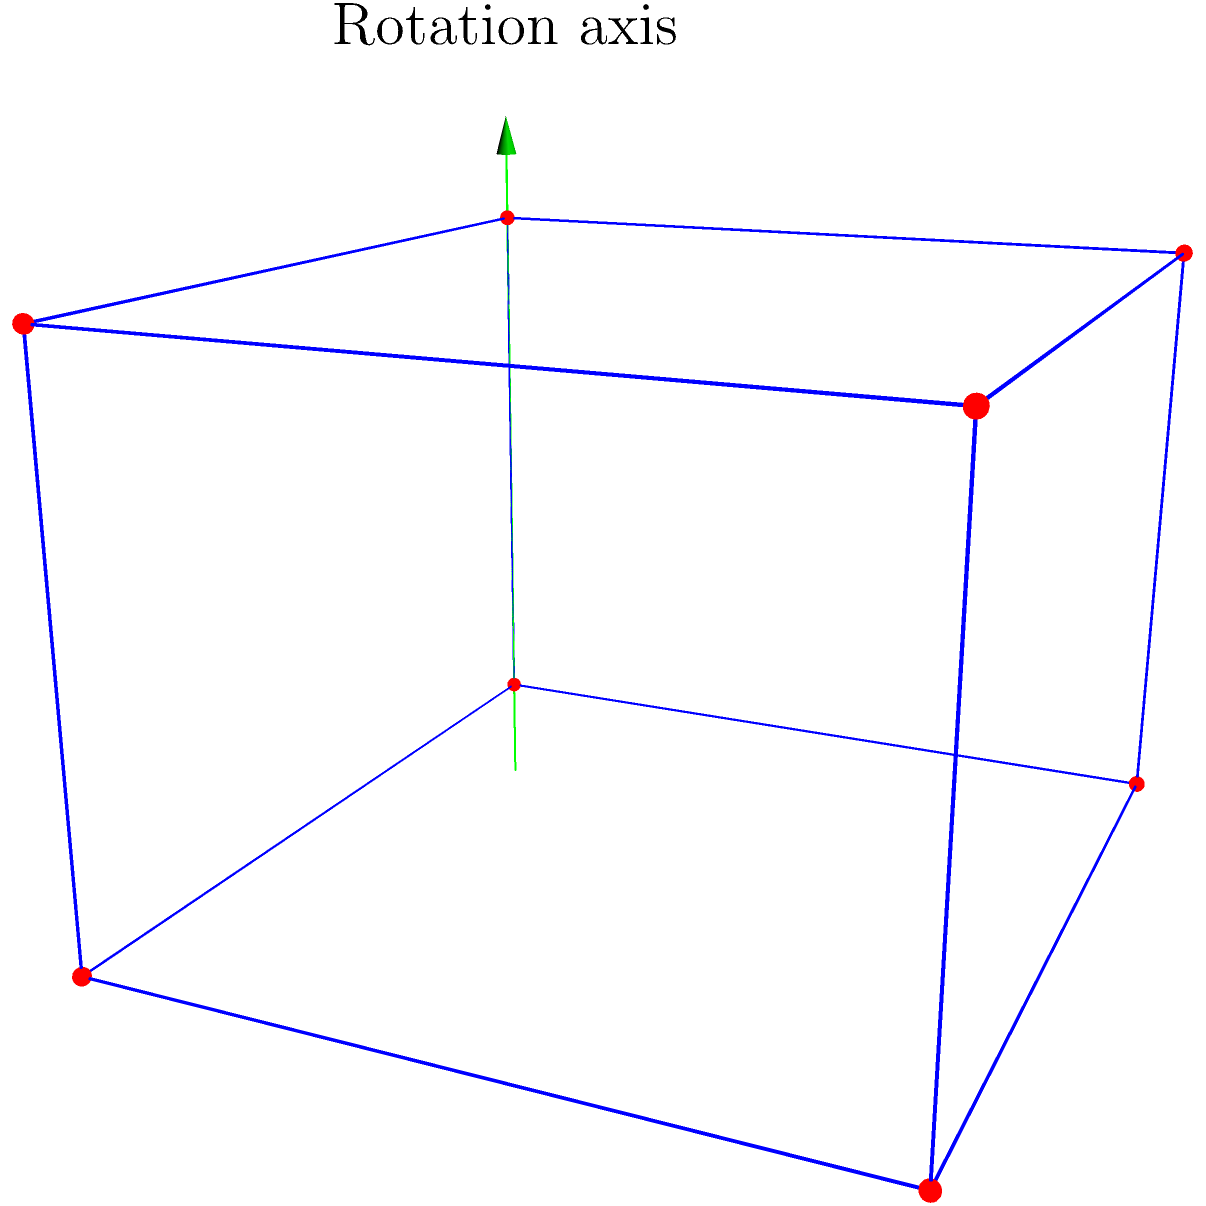Consider the cubic crystal lattice shown above. If this lattice is rotated by 120° around the axis indicated in green, how many unique orientations will the lattice have before returning to its original position? To solve this problem, we need to consider the rotational symmetry of the cubic crystal lattice:

1. The cubic lattice has 4-fold rotational symmetry around each axis parallel to its edges. This means a 90° rotation will bring the lattice back to its original orientation.

2. The green axis in the diagram passes through a vertex of the cube and the center of the opposite face. This is known as a body diagonal of the cube.

3. The body diagonal of a cube has 3-fold rotational symmetry. This means that a rotation of 360°/3 = 120° around this axis will bring the lattice to a new, but equivalent, orientation.

4. To determine how many unique orientations we'll see before returning to the original position, we need to consider how many 120° rotations it takes to complete a full 360° rotation:

   $360° ÷ 120° = 3$

5. This means that after three 120° rotations, the lattice will return to its original orientation.

6. Therefore, including the original position, there are 3 unique orientations of the lattice when rotated by 120° around the body diagonal axis.
Answer: 3 orientations 